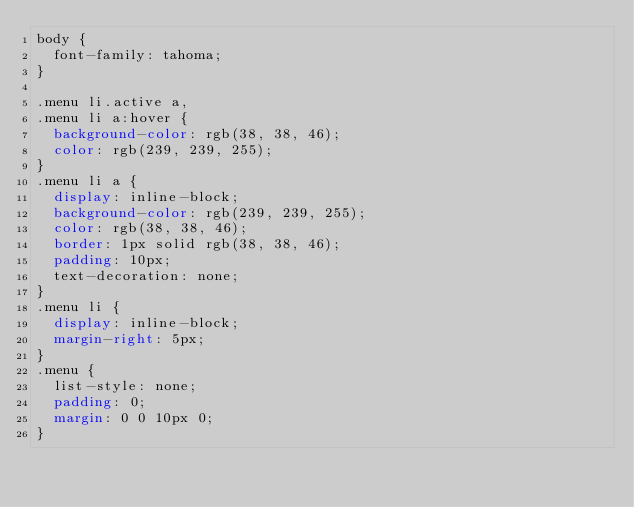Convert code to text. <code><loc_0><loc_0><loc_500><loc_500><_CSS_>body {
  font-family: tahoma;
}

.menu li.active a,
.menu li a:hover {
  background-color: rgb(38, 38, 46);
  color: rgb(239, 239, 255);
}
.menu li a {
  display: inline-block;
  background-color: rgb(239, 239, 255);
  color: rgb(38, 38, 46);
  border: 1px solid rgb(38, 38, 46);
  padding: 10px;
  text-decoration: none;
}
.menu li {
  display: inline-block;
  margin-right: 5px;
}
.menu {
  list-style: none;
  padding: 0;
  margin: 0 0 10px 0;
}
</code> 